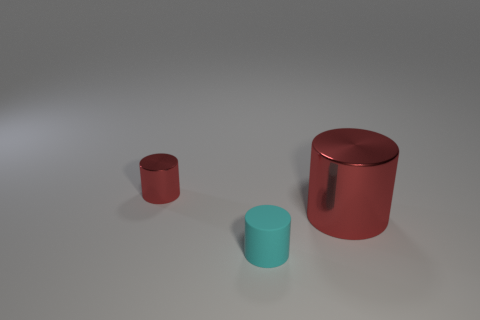Add 2 blue objects. How many objects exist? 5 Add 2 small things. How many small things exist? 4 Subtract 0 green cylinders. How many objects are left? 3 Subtract all red cylinders. Subtract all large yellow matte cylinders. How many objects are left? 1 Add 1 big red cylinders. How many big red cylinders are left? 2 